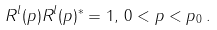Convert formula to latex. <formula><loc_0><loc_0><loc_500><loc_500>R ^ { l } ( p ) R ^ { l } ( p ) ^ { * } = 1 , \, 0 < p < p _ { 0 } \, .</formula> 